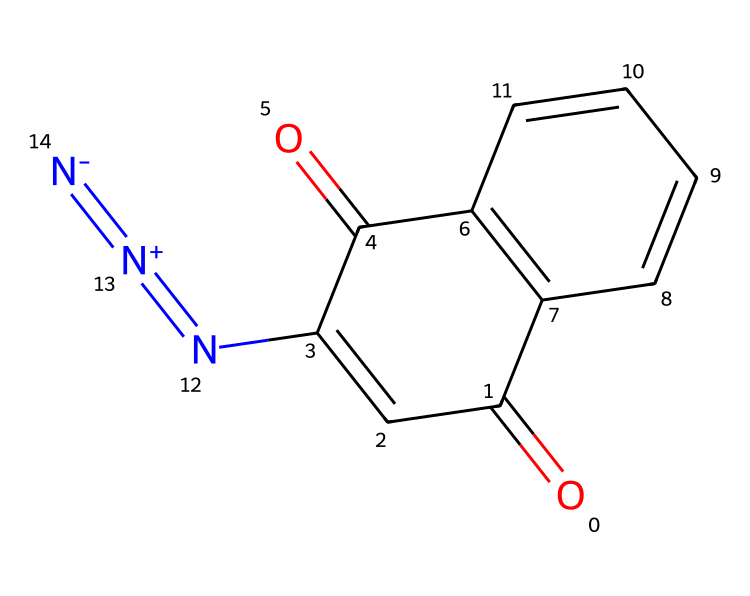What is the molecular formula of diazonaphthoquinone? By analyzing the chemical structure provided, we count the number of each type of atom present. For this structure, we identify 13 carbons (C), 8 hydrogens (H), 4 oxygens (O), and 3 nitrogens (N). Therefore, the molecular formula can be derived as C13H8N4O2.
Answer: C13H8N4O2 How many rings are present in diazonaphthoquinone? By examining the structure, we can visually identify the distinct cyclic components in the molecule. There are two fused aromatic rings in the structure. Hence, the total number of rings is two.
Answer: 2 What functional groups are present in diazonaphthoquinone? Assessing the structure reveals that several functional groups are present, including carbonyl (C=O) groups and a diazo group (N=N+). These contribute to the properties and reactivity of the compound in photoresist applications.
Answer: carbonyl and diazo What is the significance of the diazo group in photoresists? The diazo group in this chemical plays a crucial role in the photoresist process because it is responsible for the light-sensitive properties that allow for changes in solubility upon exposure to UV light. This enables patterning in photolithography.
Answer: light-sensitive properties What is the total number of nitrogen atoms in the diazonaphthoquinone structure? By closely inspecting the SMILES representation and the structure itself, we locate three nitrogen atoms represented in the compound. Therefore, the total count is three.
Answer: 3 What type of reaction is facilitated by the diazonaphthoquinone under UV light? When diazonaphthoquinone is exposed to UV light, it undergoes a photochemical reaction, leading to the breaking of the diazo bond and the formation of reactive intermediates. This results in changes to the polymer structure, impacting solubility.
Answer: photochemical reaction 